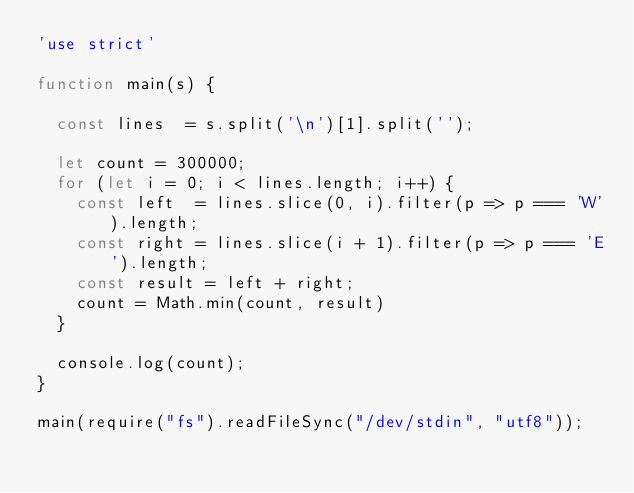Convert code to text. <code><loc_0><loc_0><loc_500><loc_500><_JavaScript_>'use strict'

function main(s) {

  const lines  = s.split('\n')[1].split('');

  let count = 300000;
  for (let i = 0; i < lines.length; i++) {
    const left  = lines.slice(0, i).filter(p => p === 'W').length;
    const right = lines.slice(i + 1).filter(p => p === 'E').length;
    const result = left + right;
    count = Math.min(count, result)
  }

  console.log(count);
}

main(require("fs").readFileSync("/dev/stdin", "utf8"));
</code> 